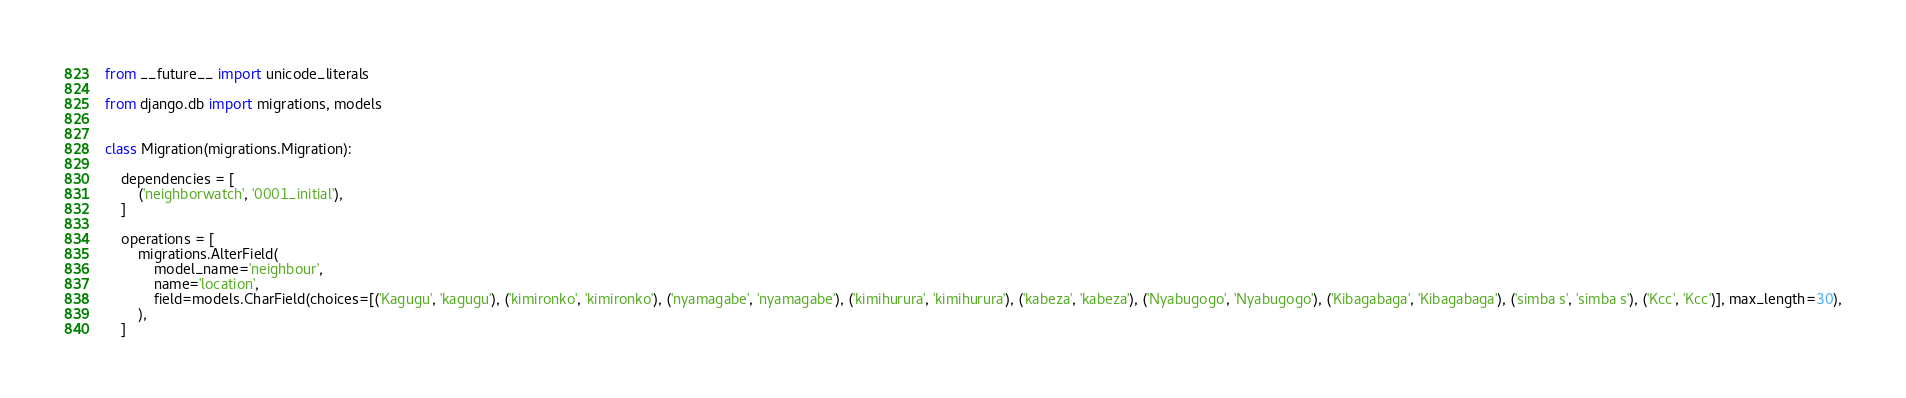<code> <loc_0><loc_0><loc_500><loc_500><_Python_>from __future__ import unicode_literals

from django.db import migrations, models


class Migration(migrations.Migration):

    dependencies = [
        ('neighborwatch', '0001_initial'),
    ]

    operations = [
        migrations.AlterField(
            model_name='neighbour',
            name='location',
            field=models.CharField(choices=[('Kagugu', 'kagugu'), ('kimironko', 'kimironko'), ('nyamagabe', 'nyamagabe'), ('kimihurura', 'kimihurura'), ('kabeza', 'kabeza'), ('Nyabugogo', 'Nyabugogo'), ('Kibagabaga', 'Kibagabaga'), ('simba s', 'simba s'), ('Kcc', 'Kcc')], max_length=30),
        ),
    ]
</code> 